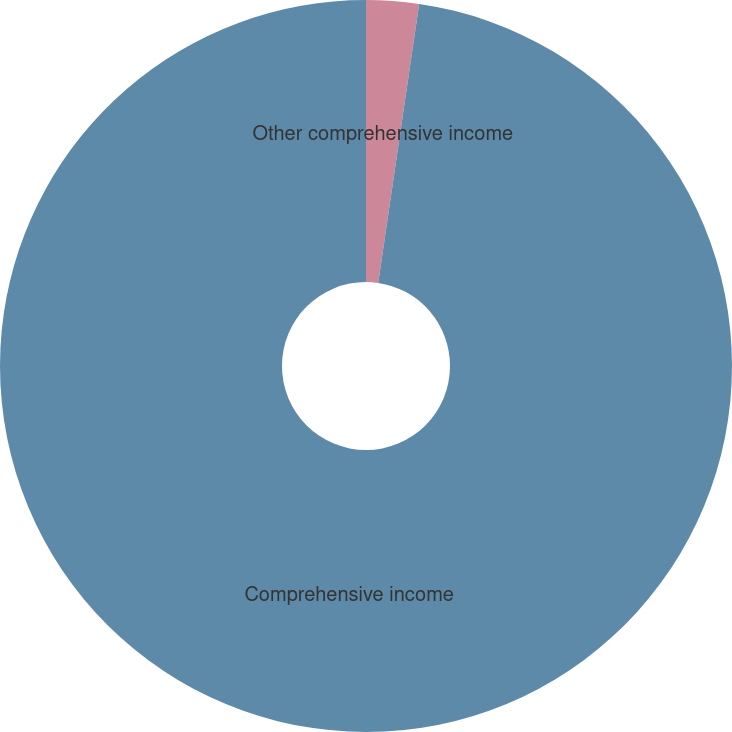<chart> <loc_0><loc_0><loc_500><loc_500><pie_chart><fcel>Other comprehensive income<fcel>Comprehensive income<nl><fcel>2.32%<fcel>97.68%<nl></chart> 